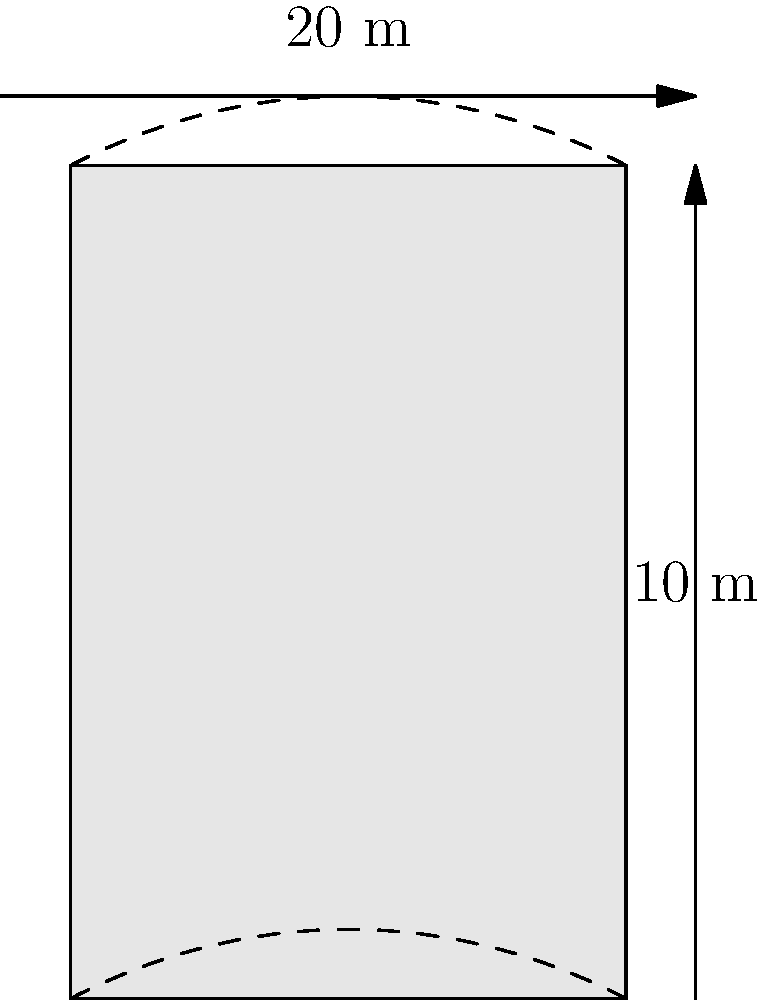In the warehouse of your manufacturing company, there are 5 identical cylindrical storage tanks. Each tank has a height of 10 meters and a diameter of 20 meters. As part of a safety audit, you need to calculate the total surface area (including the top and bottom) of all 5 tanks combined. What is the total surface area in square meters? Let's approach this step-by-step:

1) For a single cylindrical tank, we need to calculate:
   a) The area of the circular top and bottom
   b) The area of the curved side

2) Area of circular top/bottom:
   $A_{circle} = \pi r^2 = \pi (10^2) = 100\pi$ m²
   There are two circular ends, so: $2(100\pi) = 200\pi$ m²

3) Area of curved side:
   $A_{side} = 2\pi rh = 2\pi (10)(10) = 200\pi$ m²

4) Total surface area of one tank:
   $A_{total} = 200\pi + 200\pi = 400\pi$ m²

5) For 5 tanks:
   $A_{5 tanks} = 5(400\pi) = 2000\pi$ m²

6) Converting to a numerical value:
   $2000\pi \approx 6283.19$ m²

Therefore, the total surface area of all 5 tanks is approximately 6283.19 square meters.
Answer: 6283.19 m² 